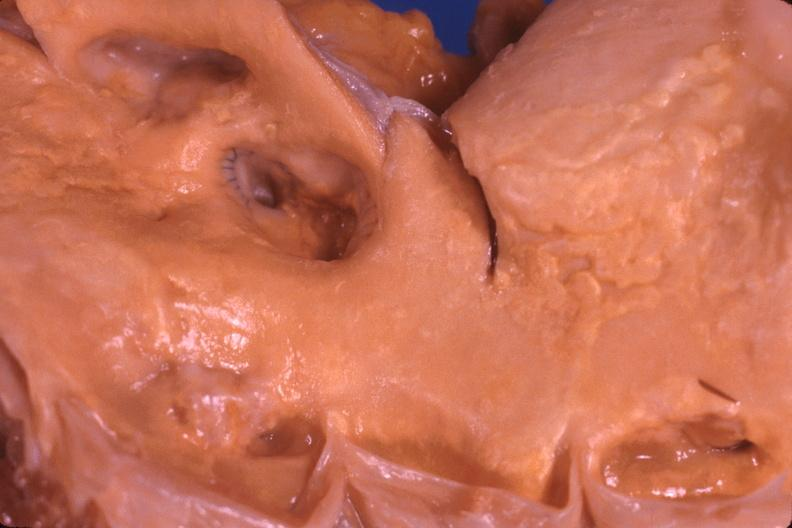what is present?
Answer the question using a single word or phrase. Cardiovascular 